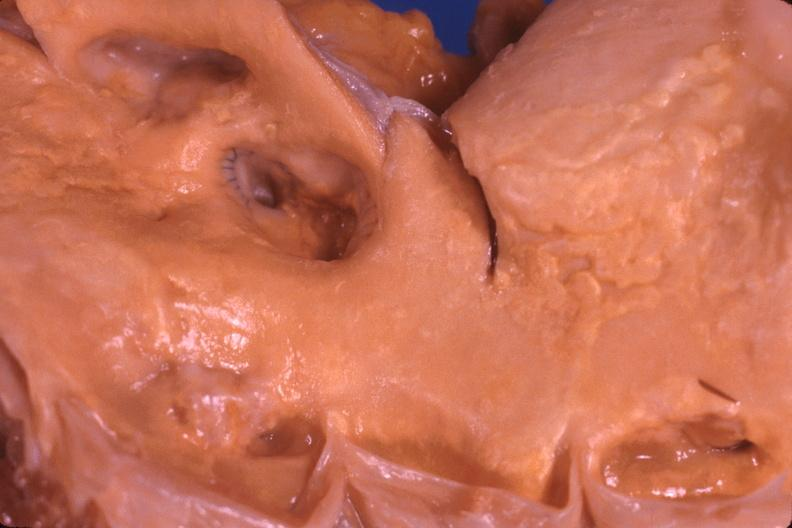what is present?
Answer the question using a single word or phrase. Cardiovascular 